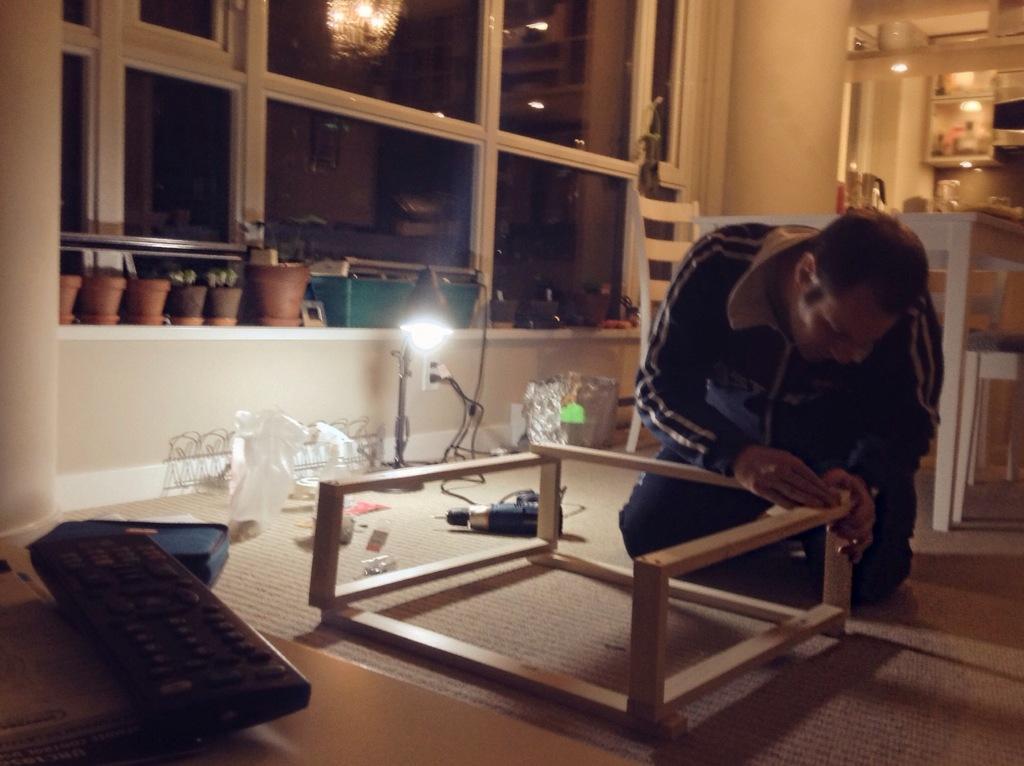Can you describe this image briefly? Here we can see that a person is sitting on the floor, and holding a wooden stick in his hands, and at back there are flower pots,and here is light, and here there are some objects. 